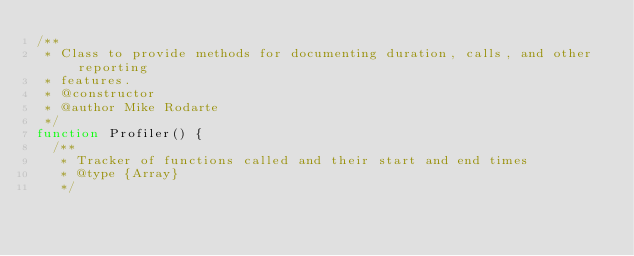Convert code to text. <code><loc_0><loc_0><loc_500><loc_500><_JavaScript_>/**
 * Class to provide methods for documenting duration, calls, and other reporting
 * features.
 * @constructor
 * @author Mike Rodarte
 */
function Profiler() {
  /**
   * Tracker of functions called and their start and end times
   * @type {Array}
   */</code> 